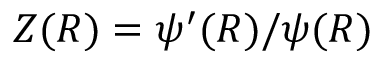Convert formula to latex. <formula><loc_0><loc_0><loc_500><loc_500>Z ( R ) = \psi ^ { \prime } ( R ) / \psi ( R )</formula> 